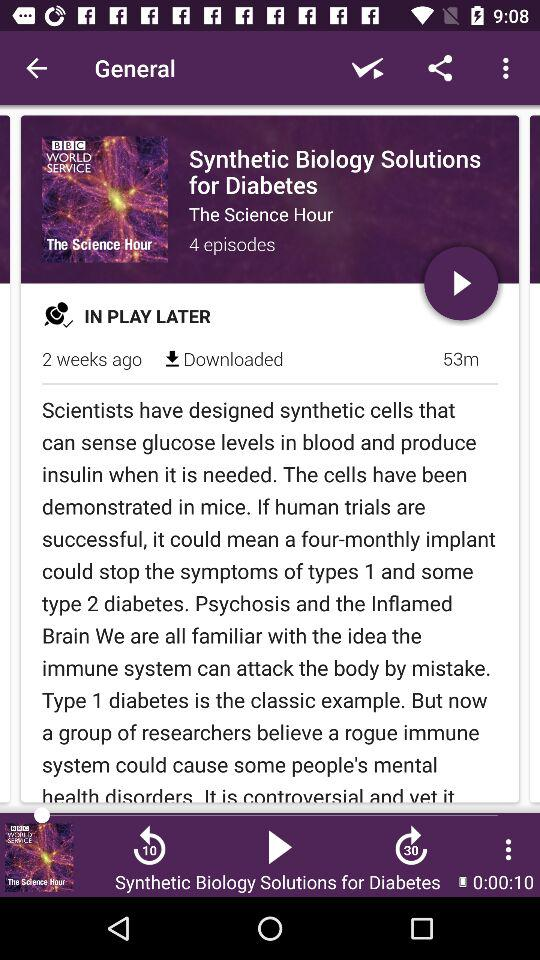How long is the Synthetic Biology Solutions for Diabetes episode?
Answer the question using a single word or phrase. 53m 